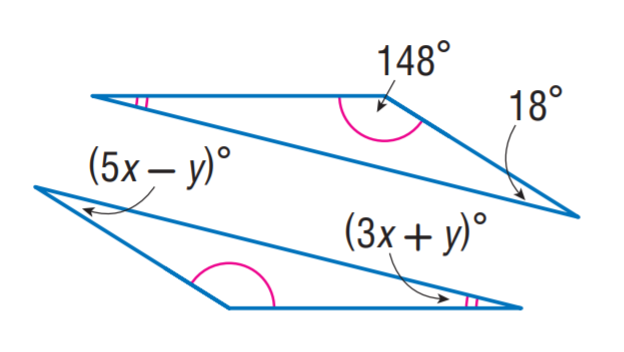Answer the mathemtical geometry problem and directly provide the correct option letter.
Question: Find y.
Choices: A: 2 B: 3 C: 4 D: 5 A 